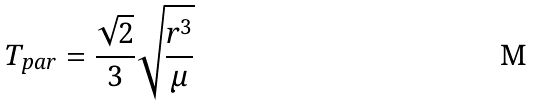<formula> <loc_0><loc_0><loc_500><loc_500>T _ { p a r } = \frac { \sqrt { 2 } } { 3 } \sqrt { \frac { r ^ { 3 } } { \mu } }</formula> 